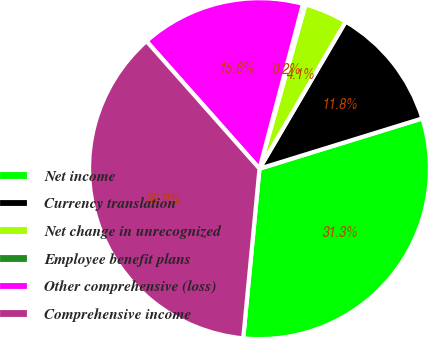Convert chart to OTSL. <chart><loc_0><loc_0><loc_500><loc_500><pie_chart><fcel>Net income<fcel>Currency translation<fcel>Net change in unrecognized<fcel>Employee benefit plans<fcel>Other comprehensive (loss)<fcel>Comprehensive income<nl><fcel>31.29%<fcel>11.8%<fcel>4.09%<fcel>0.24%<fcel>15.65%<fcel>36.94%<nl></chart> 